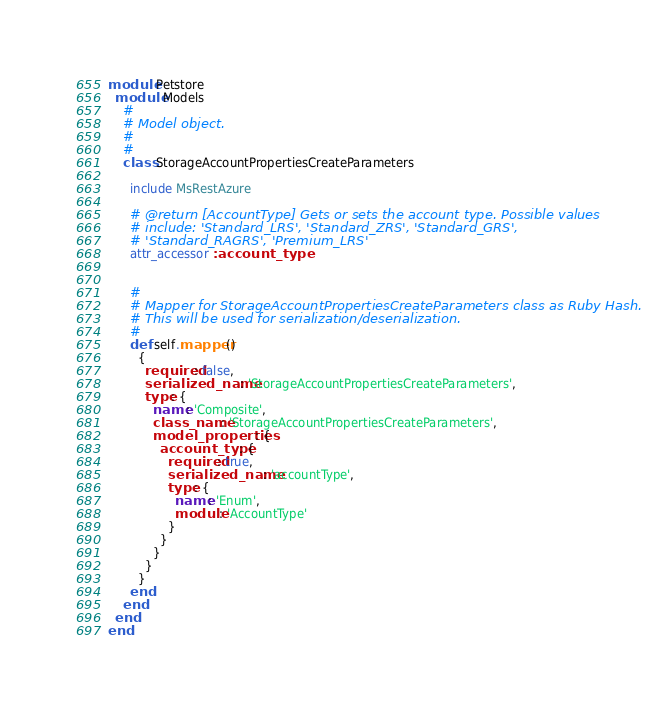Convert code to text. <code><loc_0><loc_0><loc_500><loc_500><_Ruby_>
module Petstore
  module Models
    #
    # Model object.
    #
    #
    class StorageAccountPropertiesCreateParameters

      include MsRestAzure

      # @return [AccountType] Gets or sets the account type. Possible values
      # include: 'Standard_LRS', 'Standard_ZRS', 'Standard_GRS',
      # 'Standard_RAGRS', 'Premium_LRS'
      attr_accessor :account_type


      #
      # Mapper for StorageAccountPropertiesCreateParameters class as Ruby Hash.
      # This will be used for serialization/deserialization.
      #
      def self.mapper()
        {
          required: false,
          serialized_name: 'StorageAccountPropertiesCreateParameters',
          type: {
            name: 'Composite',
            class_name: 'StorageAccountPropertiesCreateParameters',
            model_properties: {
              account_type: {
                required: true,
                serialized_name: 'accountType',
                type: {
                  name: 'Enum',
                  module: 'AccountType'
                }
              }
            }
          }
        }
      end
    end
  end
end
</code> 